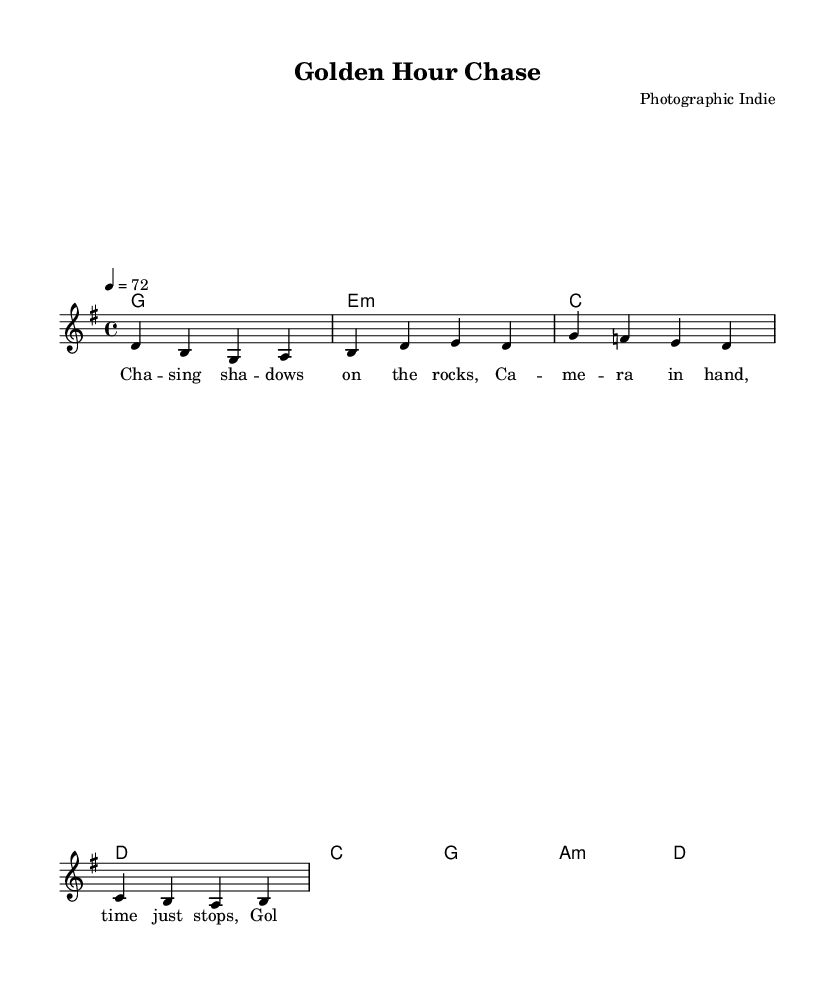What is the key signature of this music? The key signature indicates the key of G major, which has one sharp (F#). This is derived from the global settings defined at the beginning of the code.
Answer: G major What is the time signature of this music? The time signature is 4/4, indicating four beats in each measure. This is stated in the global settings section.
Answer: 4/4 What is the tempo marking of this music? The tempo marking indicates a speed of 72 beats per minute. This is found in the global section, where the tempo is set to 4 = 72.
Answer: 72 How many measures are in the verse? The verse contains four measures, as indicated by the group of notes under the voice and separated by vertical bars in the code.
Answer: 4 What are the chords used in the chorus? The chorus features the chords C, G, A minor, and D, as shown in the chord mode section of the code, where each chord is listed sequentially.
Answer: C, G, A minor, D What lyrical theme is presented in the verse? The verse speaks about capturing moments and the connection to photography while referencing shadows and a camera. This is derived from the words in the verseWords section of the code.
Answer: Shadows and camera What is the primary focus of the song's lyrics? The primary focus of the song's lyrics is about capturing fleeting beauty during the golden hour, as stated in the chorus lines that emphasize this theme of photography.
Answer: Capturing beauty 